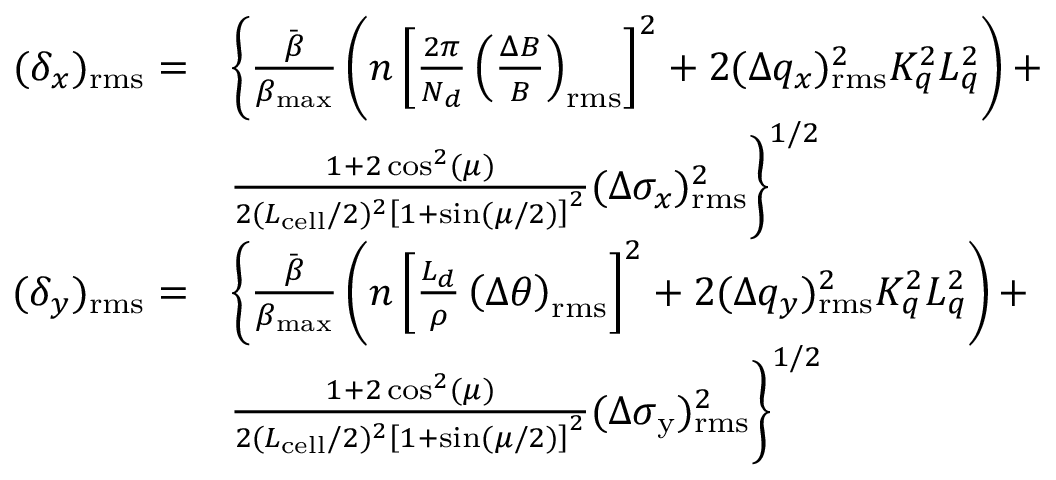Convert formula to latex. <formula><loc_0><loc_0><loc_500><loc_500>\begin{array} { r l } { ( \delta _ { x } ) _ { r m s } = } & { \left \{ \frac { \ B a r { \beta } } { \beta _ { \max } } \left ( n \left [ \frac { 2 \pi } { N _ { d } } \left ( \frac { \Delta B } { B } \right ) _ { r m s } \right ] ^ { 2 } + 2 ( \Delta q _ { x } ) _ { r m s } ^ { 2 } K _ { q } ^ { 2 } L _ { q } ^ { 2 } \right ) + } \\ & { \frac { 1 + 2 \cos ^ { 2 } ( \mu ) } { 2 ( L _ { c e l l } / 2 ) ^ { 2 } \left [ 1 + \sin ( \mu / 2 ) \right ] ^ { 2 } } ( \Delta \sigma _ { x } ) _ { r m s } ^ { 2 } \right \} ^ { 1 / 2 } } \\ { ( \delta _ { y } ) _ { r m s } = } & { \left \{ \frac { \ B a r { \beta } } { \beta _ { \max } } \left ( n \left [ \frac { L _ { d } } { \rho } \left ( \Delta \theta \right ) _ { r m s } \right ] ^ { 2 } + 2 ( \Delta q _ { y } ) _ { r m s } ^ { 2 } K _ { q } ^ { 2 } L _ { q } ^ { 2 } \right ) + } \\ & { \frac { 1 + 2 \cos ^ { 2 } ( \mu ) } { 2 ( L _ { c e l l } / 2 ) ^ { 2 } \left [ 1 + \sin ( \mu / 2 ) \right ] ^ { 2 } } ( \Delta \sigma _ { y } ) _ { r m s } ^ { 2 } \right \} ^ { 1 / 2 } } \end{array}</formula> 